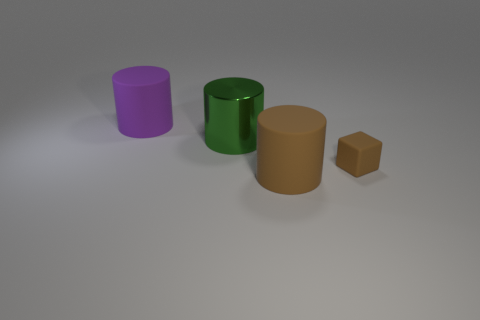Add 2 tiny green objects. How many objects exist? 6 Subtract all blocks. How many objects are left? 3 Subtract all tiny brown rubber blocks. Subtract all purple cylinders. How many objects are left? 2 Add 3 tiny brown rubber blocks. How many tiny brown rubber blocks are left? 4 Add 1 brown blocks. How many brown blocks exist? 2 Subtract 0 yellow cubes. How many objects are left? 4 